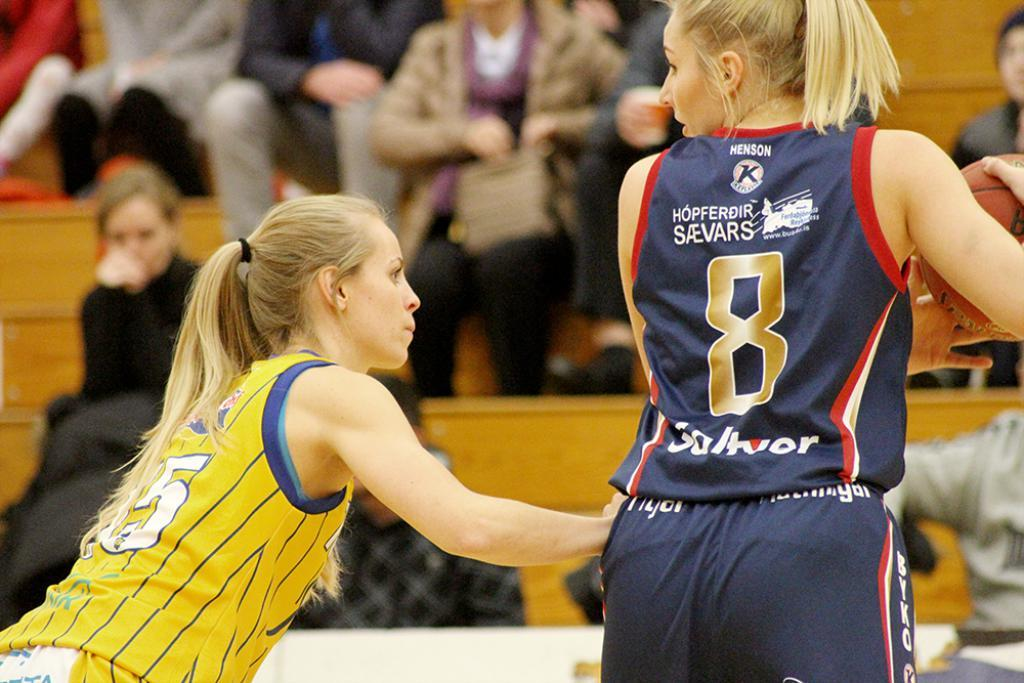<image>
Relay a brief, clear account of the picture shown. a girl basketball player with the number 8 on 